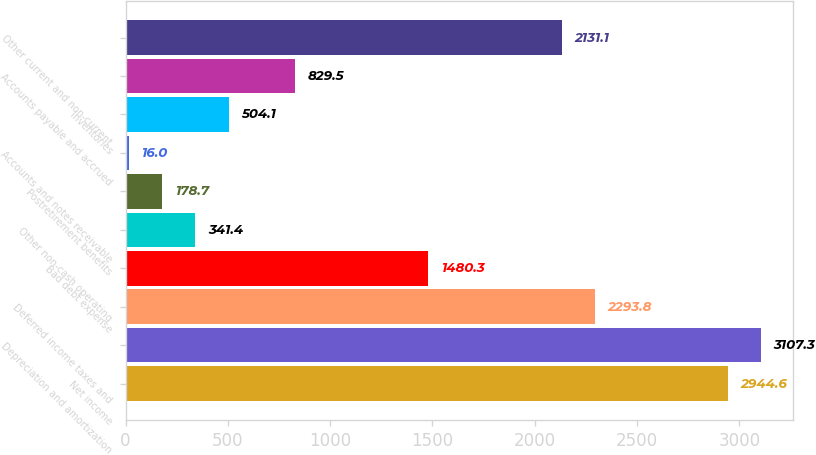Convert chart to OTSL. <chart><loc_0><loc_0><loc_500><loc_500><bar_chart><fcel>Net income<fcel>Depreciation and amortization<fcel>Deferred income taxes and<fcel>Bad debt expense<fcel>Other non-cash operating<fcel>Postretirement benefits<fcel>Accounts and notes receivable<fcel>Inventories<fcel>Accounts payable and accrued<fcel>Other current and non-current<nl><fcel>2944.6<fcel>3107.3<fcel>2293.8<fcel>1480.3<fcel>341.4<fcel>178.7<fcel>16<fcel>504.1<fcel>829.5<fcel>2131.1<nl></chart> 